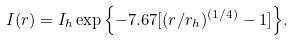<formula> <loc_0><loc_0><loc_500><loc_500>I ( r ) = I _ { h } \exp { \left \{ - 7 . 6 7 [ ( r / r _ { h } ) ^ { ( 1 / 4 ) } - 1 ] \right \} } .</formula> 